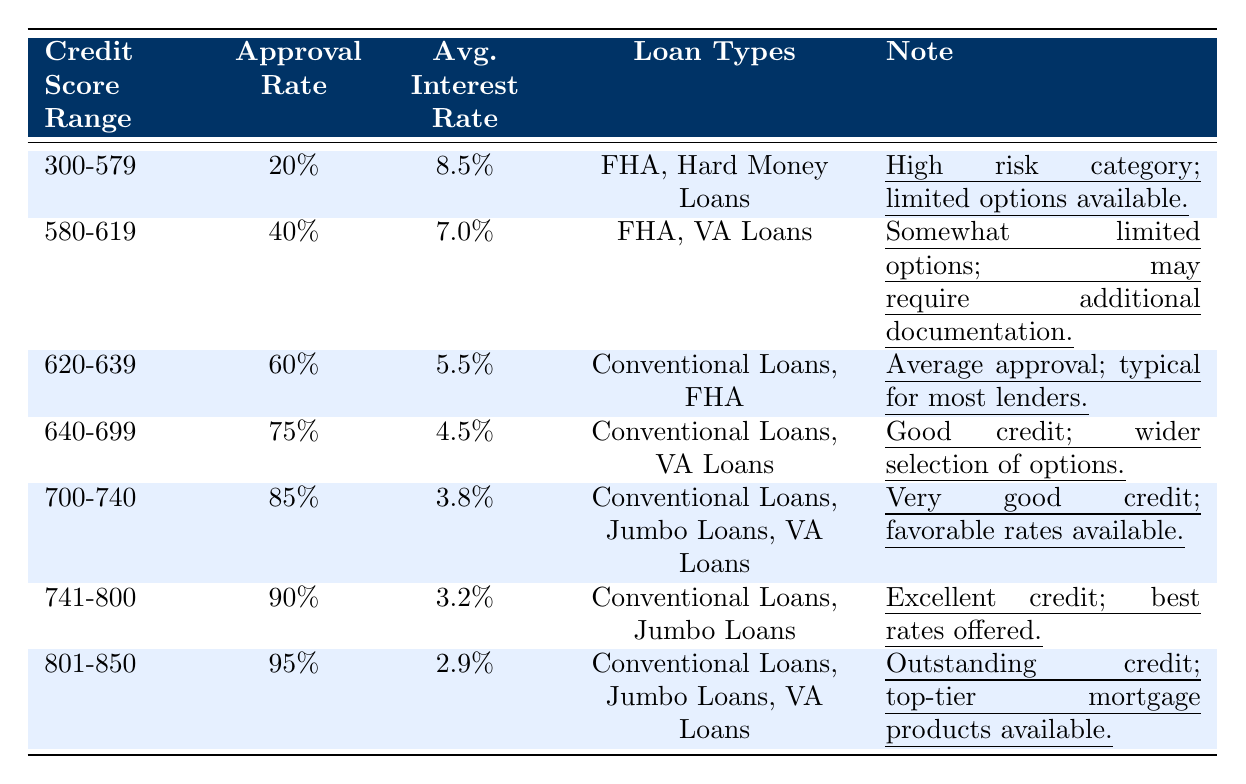What is the approval rate for the credit score range 700-740? The table shows that the approval rate for the credit score range 700-740 is 85%.
Answer: 85% Which loan types are available for credit scores between 640 and 699? According to the table, the loan types for credit scores between 640 and 699 are Conventional Loans and VA Loans.
Answer: Conventional Loans, VA Loans What is the difference in approval rates between the 580-619 and 620-639 credit score ranges? The approval rate for 580-619 is 40% and for 620-639 is 60%, so the difference is 60% - 40% = 20%.
Answer: 20% Is the average interest rate lower for credit scores of 741-800 compared to 700-740? The average interest rate for the range 741-800 is 3.2% and for 700-740 is 3.8%. Since 3.2% is less than 3.8%, the statement is true.
Answer: Yes What is the average approval rate for credit score ranges above 700? The approval rates above 700 are 85% (700-740), 90% (741-800), and 95% (801-850). The average is (85 + 90 + 95) / 3 = 90%.
Answer: 90% How many loan types are available for borrowers with credit scores of 800 and above? The table indicates that borrowers with credit scores of 801-850 have access to 3 loan types: Conventional Loans, Jumbo Loans, and VA Loans.
Answer: 3 Is there a loan type offered for credit scores below 580? According to the table, the loan types for credit scores 300-579 are FHA and Hard Money Loans, which means there are options available.
Answer: Yes What is the highest average interest rate among all credit score ranges? The highest average interest rate listed in the table is 8.5% for the credit score range 300-579.
Answer: 8.5% Calculate the sum of approval rates for all categories. The approval rates are 20%, 40%, 60%, 75%, 85%, 90%, and 95%. Adding them gives 20 + 40 + 60 + 75 + 85 + 90 + 95 = 465.
Answer: 465 What percentage of the highest credit score range (801-850) is approved for loans? The approval rate for the credit score range 801-850 is 95%.
Answer: 95% 